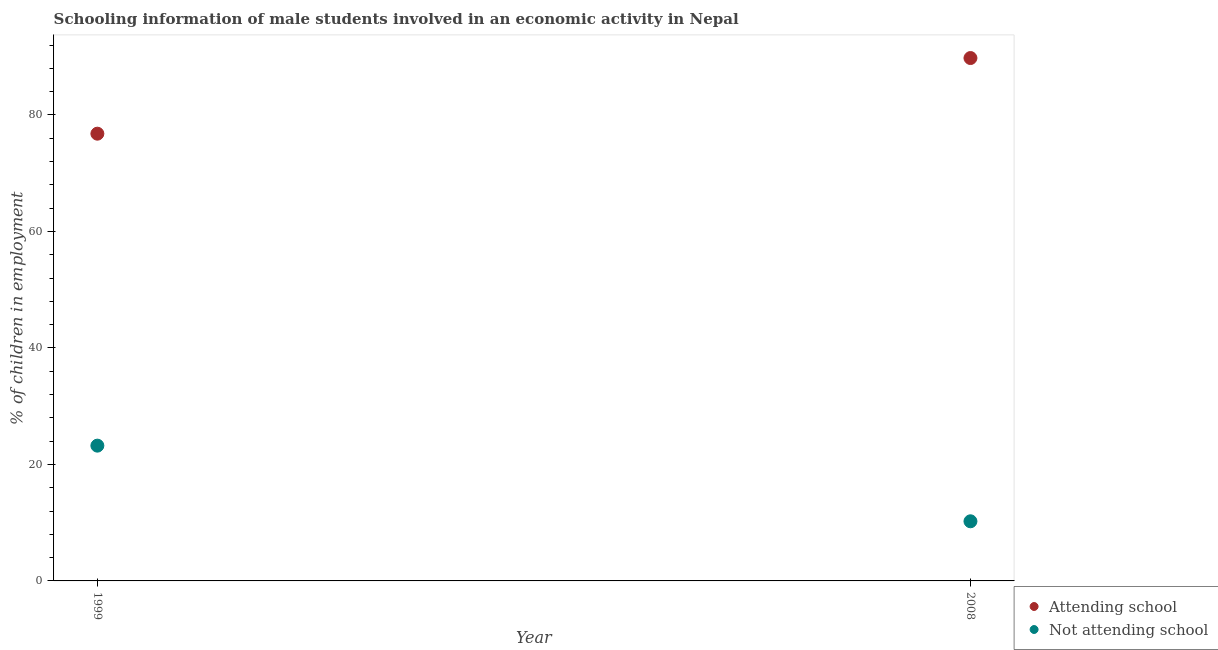Is the number of dotlines equal to the number of legend labels?
Offer a very short reply. Yes. What is the percentage of employed males who are not attending school in 2008?
Provide a short and direct response. 10.24. Across all years, what is the maximum percentage of employed males who are not attending school?
Your answer should be very brief. 23.22. Across all years, what is the minimum percentage of employed males who are not attending school?
Provide a short and direct response. 10.24. In which year was the percentage of employed males who are not attending school maximum?
Your response must be concise. 1999. In which year was the percentage of employed males who are not attending school minimum?
Offer a very short reply. 2008. What is the total percentage of employed males who are attending school in the graph?
Your answer should be very brief. 166.54. What is the difference between the percentage of employed males who are attending school in 1999 and that in 2008?
Offer a very short reply. -12.99. What is the difference between the percentage of employed males who are not attending school in 1999 and the percentage of employed males who are attending school in 2008?
Provide a succinct answer. -66.54. What is the average percentage of employed males who are not attending school per year?
Offer a very short reply. 16.73. In the year 2008, what is the difference between the percentage of employed males who are attending school and percentage of employed males who are not attending school?
Ensure brevity in your answer.  79.53. What is the ratio of the percentage of employed males who are attending school in 1999 to that in 2008?
Offer a very short reply. 0.86. In how many years, is the percentage of employed males who are attending school greater than the average percentage of employed males who are attending school taken over all years?
Make the answer very short. 1. Does the percentage of employed males who are attending school monotonically increase over the years?
Your answer should be very brief. Yes. Is the percentage of employed males who are not attending school strictly less than the percentage of employed males who are attending school over the years?
Provide a short and direct response. Yes. What is the difference between two consecutive major ticks on the Y-axis?
Provide a succinct answer. 20. Does the graph contain any zero values?
Offer a very short reply. No. How many legend labels are there?
Provide a succinct answer. 2. How are the legend labels stacked?
Keep it short and to the point. Vertical. What is the title of the graph?
Ensure brevity in your answer.  Schooling information of male students involved in an economic activity in Nepal. What is the label or title of the X-axis?
Ensure brevity in your answer.  Year. What is the label or title of the Y-axis?
Your answer should be very brief. % of children in employment. What is the % of children in employment in Attending school in 1999?
Your answer should be compact. 76.78. What is the % of children in employment of Not attending school in 1999?
Give a very brief answer. 23.22. What is the % of children in employment of Attending school in 2008?
Offer a terse response. 89.76. What is the % of children in employment of Not attending school in 2008?
Your answer should be very brief. 10.24. Across all years, what is the maximum % of children in employment in Attending school?
Ensure brevity in your answer.  89.76. Across all years, what is the maximum % of children in employment in Not attending school?
Your answer should be very brief. 23.22. Across all years, what is the minimum % of children in employment of Attending school?
Your answer should be very brief. 76.78. Across all years, what is the minimum % of children in employment in Not attending school?
Give a very brief answer. 10.24. What is the total % of children in employment of Attending school in the graph?
Your response must be concise. 166.54. What is the total % of children in employment in Not attending school in the graph?
Give a very brief answer. 33.46. What is the difference between the % of children in employment in Attending school in 1999 and that in 2008?
Offer a terse response. -12.99. What is the difference between the % of children in employment of Not attending school in 1999 and that in 2008?
Your answer should be very brief. 12.99. What is the difference between the % of children in employment of Attending school in 1999 and the % of children in employment of Not attending school in 2008?
Ensure brevity in your answer.  66.54. What is the average % of children in employment of Attending school per year?
Provide a short and direct response. 83.27. What is the average % of children in employment in Not attending school per year?
Make the answer very short. 16.73. In the year 1999, what is the difference between the % of children in employment of Attending school and % of children in employment of Not attending school?
Keep it short and to the point. 53.55. In the year 2008, what is the difference between the % of children in employment in Attending school and % of children in employment in Not attending school?
Your response must be concise. 79.53. What is the ratio of the % of children in employment of Attending school in 1999 to that in 2008?
Offer a very short reply. 0.86. What is the ratio of the % of children in employment of Not attending school in 1999 to that in 2008?
Ensure brevity in your answer.  2.27. What is the difference between the highest and the second highest % of children in employment of Attending school?
Ensure brevity in your answer.  12.99. What is the difference between the highest and the second highest % of children in employment in Not attending school?
Ensure brevity in your answer.  12.99. What is the difference between the highest and the lowest % of children in employment of Attending school?
Provide a short and direct response. 12.99. What is the difference between the highest and the lowest % of children in employment in Not attending school?
Offer a very short reply. 12.99. 